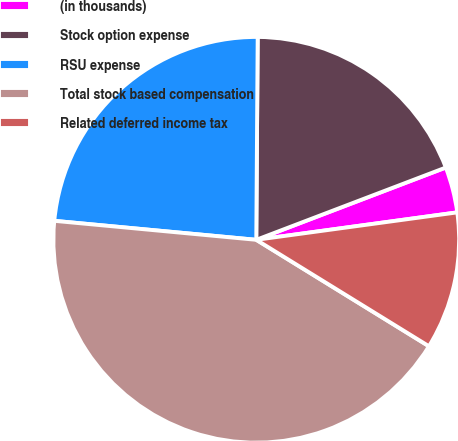Convert chart. <chart><loc_0><loc_0><loc_500><loc_500><pie_chart><fcel>(in thousands)<fcel>Stock option expense<fcel>RSU expense<fcel>Total stock based compensation<fcel>Related deferred income tax<nl><fcel>3.64%<fcel>19.09%<fcel>23.62%<fcel>42.7%<fcel>10.95%<nl></chart> 